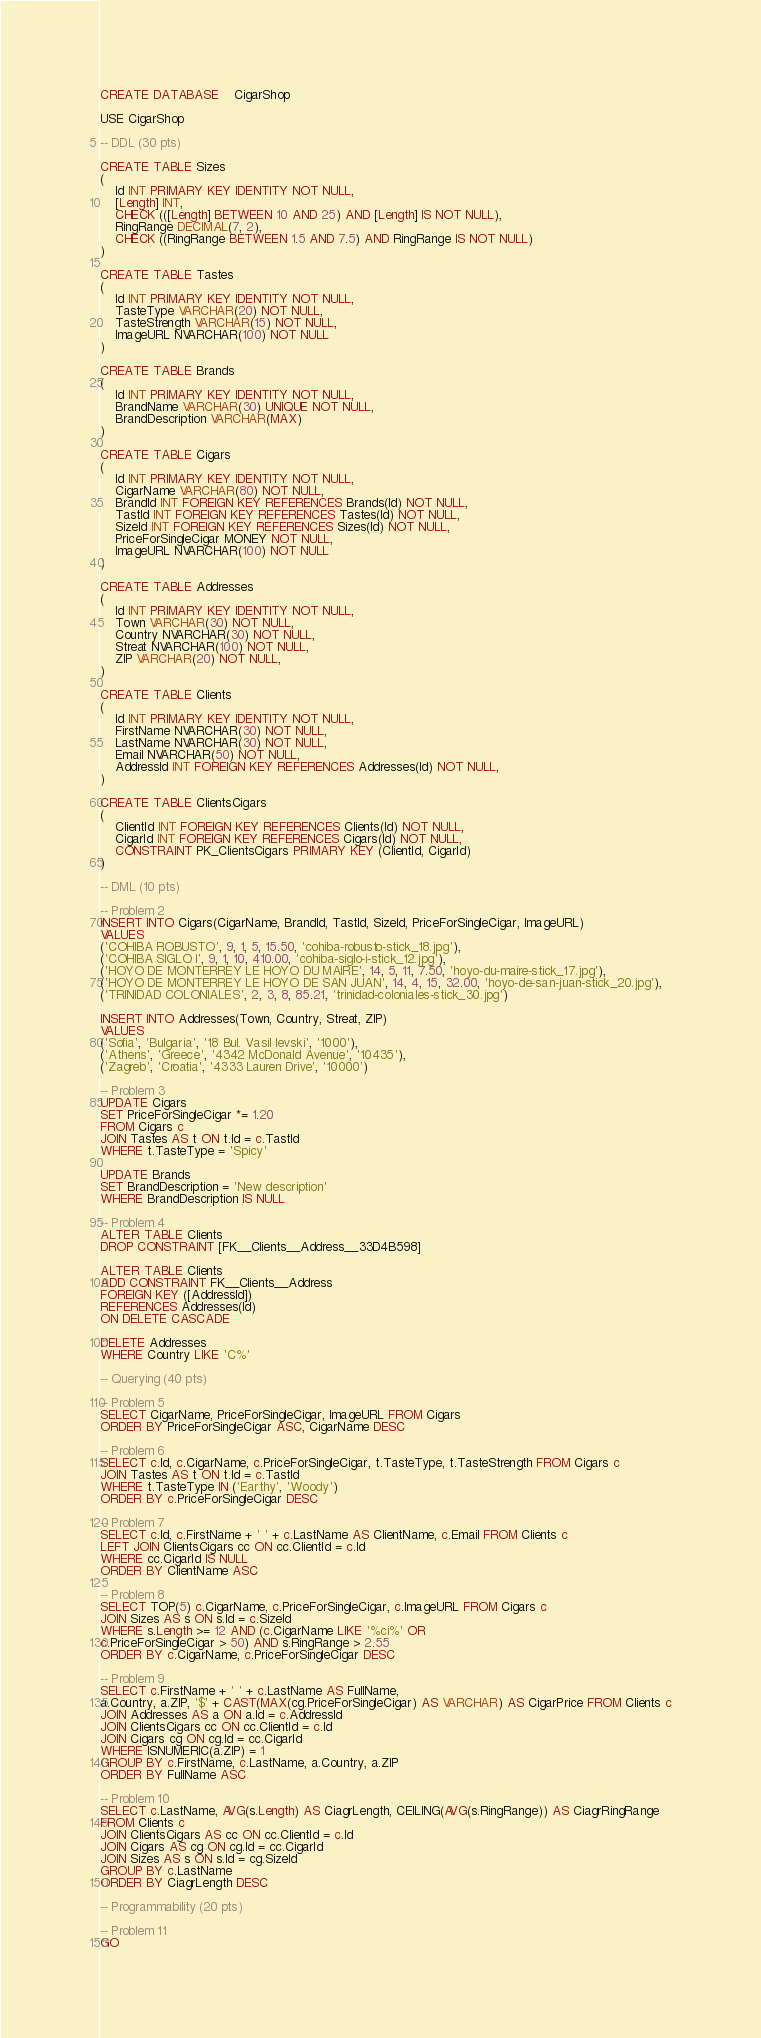Convert code to text. <code><loc_0><loc_0><loc_500><loc_500><_SQL_>CREATE DATABASE	CigarShop

USE CigarShop

-- DDL (30 pts)

CREATE TABLE Sizes
(
	Id INT PRIMARY KEY IDENTITY NOT NULL,
	[Length] INT,
	CHECK (([Length] BETWEEN 10 AND 25) AND [Length] IS NOT NULL),
	RingRange DECIMAL(7, 2),
	CHECK ((RingRange BETWEEN 1.5 AND 7.5) AND RingRange IS NOT NULL)
)

CREATE TABLE Tastes
(
	Id INT PRIMARY KEY IDENTITY NOT NULL,
	TasteType VARCHAR(20) NOT NULL,
	TasteStrength VARCHAR(15) NOT NULL,
	ImageURL NVARCHAR(100) NOT NULL
)

CREATE TABLE Brands
(
	Id INT PRIMARY KEY IDENTITY NOT NULL,
	BrandName VARCHAR(30) UNIQUE NOT NULL,
	BrandDescription VARCHAR(MAX)
)

CREATE TABLE Cigars
(
	Id INT PRIMARY KEY IDENTITY NOT NULL,
	CigarName VARCHAR(80) NOT NULL,
	BrandId INT FOREIGN KEY REFERENCES Brands(Id) NOT NULL,
	TastId INT FOREIGN KEY REFERENCES Tastes(Id) NOT NULL,
	SizeId INT FOREIGN KEY REFERENCES Sizes(Id) NOT NULL,
	PriceForSingleCigar MONEY NOT NULL,
	ImageURL NVARCHAR(100) NOT NULL
)

CREATE TABLE Addresses
(
	Id INT PRIMARY KEY IDENTITY NOT NULL,
	Town VARCHAR(30) NOT NULL,
	Country NVARCHAR(30) NOT NULL,
	Streat NVARCHAR(100) NOT NULL,
	ZIP VARCHAR(20) NOT NULL,
)

CREATE TABLE Clients
(
	Id INT PRIMARY KEY IDENTITY NOT NULL,
	FirstName NVARCHAR(30) NOT NULL,
	LastName NVARCHAR(30) NOT NULL,
	Email NVARCHAR(50) NOT NULL,
	AddressId INT FOREIGN KEY REFERENCES Addresses(Id) NOT NULL,
)

CREATE TABLE ClientsCigars
(
	ClientId INT FOREIGN KEY REFERENCES Clients(Id) NOT NULL,
	CigarId INT FOREIGN KEY REFERENCES Cigars(Id) NOT NULL,
	CONSTRAINT PK_ClientsCigars PRIMARY KEY (ClientId, CigarId)
)

-- DML (10 pts)

-- Problem 2
INSERT INTO Cigars(CigarName, BrandId, TastId, SizeId, PriceForSingleCigar, ImageURL)
VALUES
('COHIBA ROBUSTO', 9, 1, 5, 15.50, 'cohiba-robusto-stick_18.jpg'),
('COHIBA SIGLO I', 9, 1, 10, 410.00, 'cohiba-siglo-i-stick_12.jpg'),
('HOYO DE MONTERREY LE HOYO DU MAIRE', 14, 5, 11, 7.50, 'hoyo-du-maire-stick_17.jpg'),
('HOYO DE MONTERREY LE HOYO DE SAN JUAN', 14, 4, 15, 32.00, 'hoyo-de-san-juan-stick_20.jpg'),
('TRINIDAD COLONIALES', 2, 3, 8, 85.21, 'trinidad-coloniales-stick_30.jpg')

INSERT INTO Addresses(Town, Country, Streat, ZIP)
VALUES
('Sofia', 'Bulgaria', '18 Bul. Vasil levski', '1000'),
('Athens', 'Greece', '4342 McDonald Avenue', '10435'),
('Zagreb', 'Croatia', '4333 Lauren Drive', '10000')

-- Problem 3
UPDATE Cigars
SET PriceForSingleCigar *= 1.20
FROM Cigars c
JOIN Tastes AS t ON t.Id = c.TastId
WHERE t.TasteType = 'Spicy'

UPDATE Brands
SET BrandDescription = 'New description'
WHERE BrandDescription IS NULL

-- Problem 4
ALTER TABLE Clients
DROP CONSTRAINT [FK__Clients__Address__33D4B598]

ALTER TABLE Clients
ADD CONSTRAINT FK__Clients__Address
FOREIGN KEY ([AddressId])
REFERENCES Addresses(Id)
ON DELETE CASCADE

DELETE Addresses
WHERE Country LIKE 'C%'

-- Querying (40 pts)

-- Problem 5
SELECT CigarName, PriceForSingleCigar, ImageURL FROM Cigars
ORDER BY PriceForSingleCigar ASC, CigarName DESC

-- Problem 6
SELECT c.Id, c.CigarName, c.PriceForSingleCigar, t.TasteType, t.TasteStrength FROM Cigars c
JOIN Tastes AS t ON t.Id = c.TastId
WHERE t.TasteType IN ('Earthy', 'Woody')
ORDER BY c.PriceForSingleCigar DESC

-- Problem 7
SELECT c.Id, c.FirstName + ' ' + c.LastName AS ClientName, c.Email FROM Clients c
LEFT JOIN ClientsCigars cc ON cc.ClientId = c.Id
WHERE cc.CigarId IS NULL
ORDER BY ClientName ASC

-- Problem 8
SELECT TOP(5) c.CigarName, c.PriceForSingleCigar, c.ImageURL FROM Cigars c
JOIN Sizes AS s ON s.Id = c.SizeId
WHERE s.Length >= 12 AND (c.CigarName LIKE '%ci%' OR 
c.PriceForSingleCigar > 50) AND s.RingRange > 2.55
ORDER BY c.CigarName, c.PriceForSingleCigar DESC

-- Problem 9
SELECT c.FirstName + ' ' + c.LastName AS FullName, 
a.Country, a.ZIP, '$' + CAST(MAX(cg.PriceForSingleCigar) AS VARCHAR) AS CigarPrice FROM Clients c
JOIN Addresses AS a ON a.Id = c.AddressId
JOIN ClientsCigars cc ON cc.ClientId = c.Id
JOIN Cigars cg ON cg.Id = cc.CigarId
WHERE ISNUMERIC(a.ZIP) = 1
GROUP BY c.FirstName, c.LastName, a.Country, a.ZIP
ORDER BY FullName ASC

-- Problem 10
SELECT c.LastName, AVG(s.Length) AS CiagrLength, CEILING(AVG(s.RingRange)) AS CiagrRingRange 
FROM Clients c
JOIN ClientsCigars AS cc ON cc.ClientId = c.Id
JOIN Cigars AS cg ON cg.Id = cc.CigarId
JOIN Sizes AS s ON s.Id = cg.SizeId
GROUP BY c.LastName
ORDER BY CiagrLength DESC

-- Programmability (20 pts)

-- Problem 11
GO
</code> 